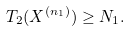Convert formula to latex. <formula><loc_0><loc_0><loc_500><loc_500>T _ { 2 } ( X ^ { \left ( n _ { 1 } \right ) } ) \geq N _ { 1 } .</formula> 